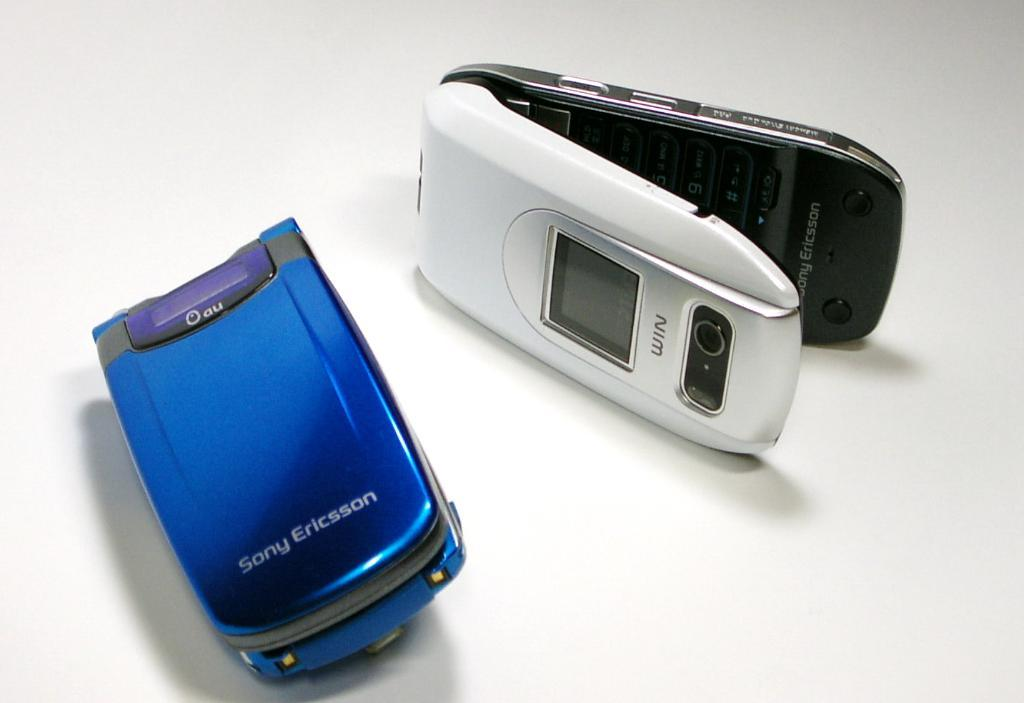Provide a one-sentence caption for the provided image. A blue flip phone from Sony Ericsson and a white as well. 